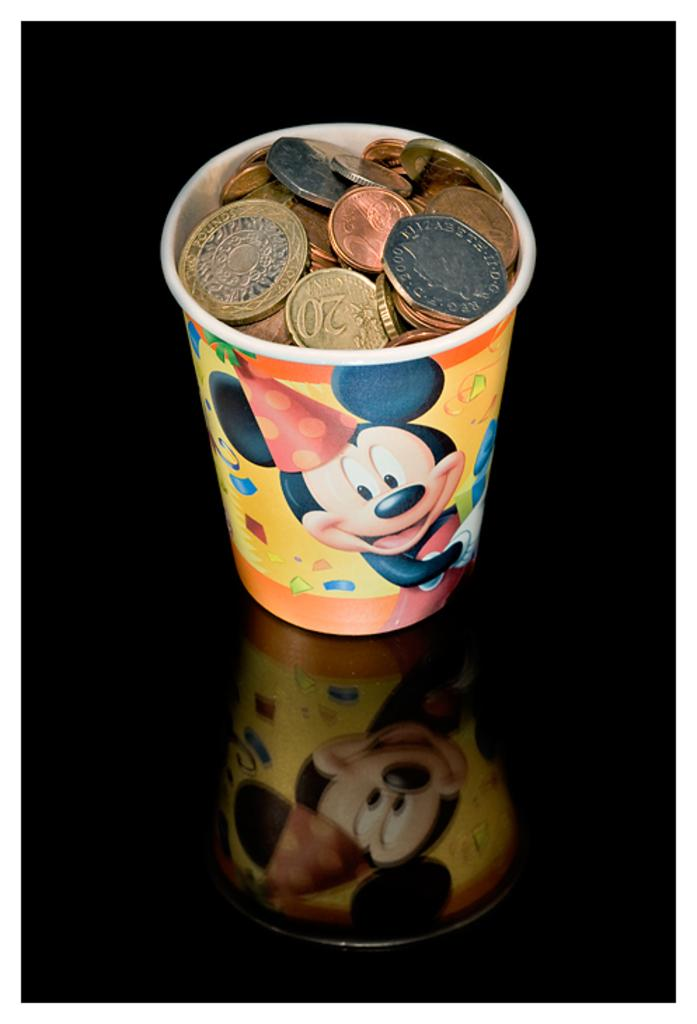What objects are present in the image? There are coins in the image. Where are the coins located? The coins are in a glass. Can you describe the position of the glass in the image? The glass is placed on a surface. What type of quilt is being used to cover the train tracks in the image? There is no quilt or train tracks present in the image; it only features coins in a glass. 